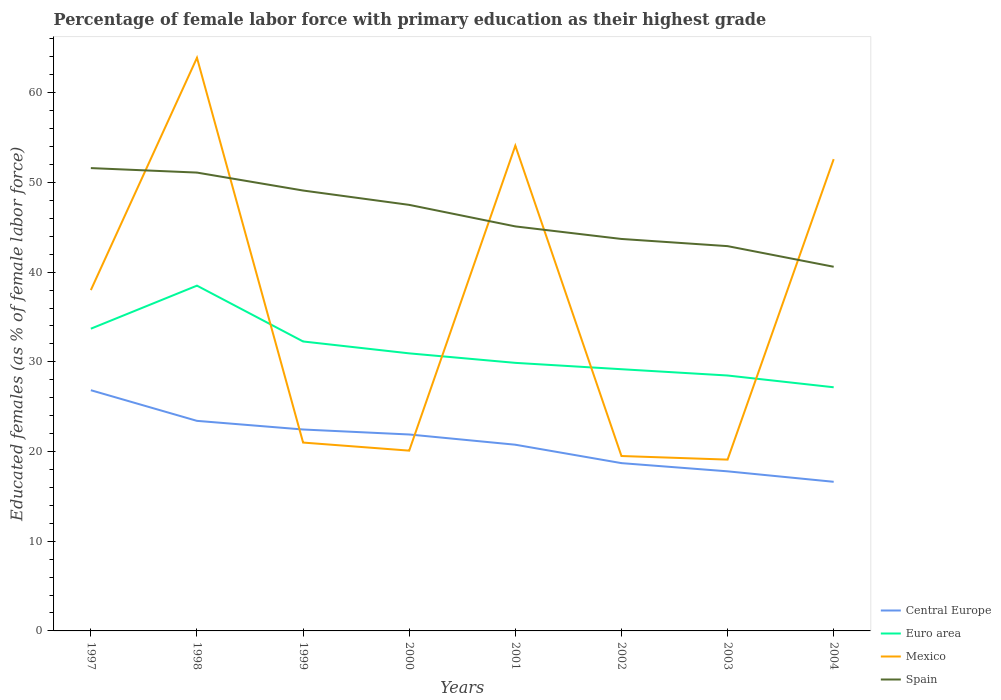How many different coloured lines are there?
Offer a terse response. 4. Across all years, what is the maximum percentage of female labor force with primary education in Mexico?
Your response must be concise. 19.1. What is the total percentage of female labor force with primary education in Euro area in the graph?
Your answer should be very brief. 6.53. What is the difference between the highest and the second highest percentage of female labor force with primary education in Central Europe?
Your answer should be compact. 10.21. What is the difference between the highest and the lowest percentage of female labor force with primary education in Euro area?
Make the answer very short. 3. How many years are there in the graph?
Your response must be concise. 8. What is the difference between two consecutive major ticks on the Y-axis?
Offer a terse response. 10. Does the graph contain any zero values?
Make the answer very short. No. How many legend labels are there?
Make the answer very short. 4. What is the title of the graph?
Offer a terse response. Percentage of female labor force with primary education as their highest grade. What is the label or title of the X-axis?
Provide a short and direct response. Years. What is the label or title of the Y-axis?
Offer a terse response. Educated females (as % of female labor force). What is the Educated females (as % of female labor force) of Central Europe in 1997?
Your answer should be very brief. 26.84. What is the Educated females (as % of female labor force) in Euro area in 1997?
Provide a succinct answer. 33.69. What is the Educated females (as % of female labor force) of Mexico in 1997?
Provide a succinct answer. 38. What is the Educated females (as % of female labor force) in Spain in 1997?
Provide a succinct answer. 51.6. What is the Educated females (as % of female labor force) of Central Europe in 1998?
Make the answer very short. 23.42. What is the Educated females (as % of female labor force) in Euro area in 1998?
Your answer should be very brief. 38.49. What is the Educated females (as % of female labor force) of Mexico in 1998?
Keep it short and to the point. 63.9. What is the Educated females (as % of female labor force) in Spain in 1998?
Keep it short and to the point. 51.1. What is the Educated females (as % of female labor force) of Central Europe in 1999?
Give a very brief answer. 22.46. What is the Educated females (as % of female labor force) of Euro area in 1999?
Your answer should be very brief. 32.27. What is the Educated females (as % of female labor force) of Mexico in 1999?
Offer a terse response. 21. What is the Educated females (as % of female labor force) in Spain in 1999?
Provide a short and direct response. 49.1. What is the Educated females (as % of female labor force) in Central Europe in 2000?
Ensure brevity in your answer.  21.9. What is the Educated females (as % of female labor force) of Euro area in 2000?
Provide a succinct answer. 30.95. What is the Educated females (as % of female labor force) of Mexico in 2000?
Provide a succinct answer. 20.1. What is the Educated females (as % of female labor force) of Spain in 2000?
Provide a succinct answer. 47.5. What is the Educated females (as % of female labor force) in Central Europe in 2001?
Offer a terse response. 20.76. What is the Educated females (as % of female labor force) in Euro area in 2001?
Offer a very short reply. 29.89. What is the Educated females (as % of female labor force) in Mexico in 2001?
Give a very brief answer. 54.1. What is the Educated females (as % of female labor force) of Spain in 2001?
Your answer should be very brief. 45.1. What is the Educated females (as % of female labor force) of Central Europe in 2002?
Ensure brevity in your answer.  18.71. What is the Educated females (as % of female labor force) in Euro area in 2002?
Ensure brevity in your answer.  29.18. What is the Educated females (as % of female labor force) of Mexico in 2002?
Give a very brief answer. 19.5. What is the Educated females (as % of female labor force) of Spain in 2002?
Your answer should be very brief. 43.7. What is the Educated females (as % of female labor force) of Central Europe in 2003?
Provide a short and direct response. 17.79. What is the Educated females (as % of female labor force) of Euro area in 2003?
Offer a terse response. 28.48. What is the Educated females (as % of female labor force) of Mexico in 2003?
Keep it short and to the point. 19.1. What is the Educated females (as % of female labor force) in Spain in 2003?
Offer a very short reply. 42.9. What is the Educated females (as % of female labor force) of Central Europe in 2004?
Ensure brevity in your answer.  16.63. What is the Educated females (as % of female labor force) of Euro area in 2004?
Give a very brief answer. 27.16. What is the Educated females (as % of female labor force) in Mexico in 2004?
Make the answer very short. 52.6. What is the Educated females (as % of female labor force) of Spain in 2004?
Your answer should be compact. 40.6. Across all years, what is the maximum Educated females (as % of female labor force) in Central Europe?
Provide a succinct answer. 26.84. Across all years, what is the maximum Educated females (as % of female labor force) in Euro area?
Provide a succinct answer. 38.49. Across all years, what is the maximum Educated females (as % of female labor force) of Mexico?
Ensure brevity in your answer.  63.9. Across all years, what is the maximum Educated females (as % of female labor force) of Spain?
Give a very brief answer. 51.6. Across all years, what is the minimum Educated females (as % of female labor force) of Central Europe?
Offer a terse response. 16.63. Across all years, what is the minimum Educated females (as % of female labor force) of Euro area?
Offer a terse response. 27.16. Across all years, what is the minimum Educated females (as % of female labor force) in Mexico?
Keep it short and to the point. 19.1. Across all years, what is the minimum Educated females (as % of female labor force) in Spain?
Make the answer very short. 40.6. What is the total Educated females (as % of female labor force) of Central Europe in the graph?
Offer a very short reply. 168.5. What is the total Educated females (as % of female labor force) in Euro area in the graph?
Offer a terse response. 250.11. What is the total Educated females (as % of female labor force) in Mexico in the graph?
Offer a very short reply. 288.3. What is the total Educated females (as % of female labor force) in Spain in the graph?
Ensure brevity in your answer.  371.6. What is the difference between the Educated females (as % of female labor force) in Central Europe in 1997 and that in 1998?
Your response must be concise. 3.42. What is the difference between the Educated females (as % of female labor force) in Euro area in 1997 and that in 1998?
Give a very brief answer. -4.8. What is the difference between the Educated females (as % of female labor force) of Mexico in 1997 and that in 1998?
Ensure brevity in your answer.  -25.9. What is the difference between the Educated females (as % of female labor force) of Central Europe in 1997 and that in 1999?
Provide a succinct answer. 4.38. What is the difference between the Educated females (as % of female labor force) of Euro area in 1997 and that in 1999?
Keep it short and to the point. 1.42. What is the difference between the Educated females (as % of female labor force) of Mexico in 1997 and that in 1999?
Provide a succinct answer. 17. What is the difference between the Educated females (as % of female labor force) in Central Europe in 1997 and that in 2000?
Ensure brevity in your answer.  4.93. What is the difference between the Educated females (as % of female labor force) of Euro area in 1997 and that in 2000?
Offer a terse response. 2.75. What is the difference between the Educated females (as % of female labor force) of Mexico in 1997 and that in 2000?
Make the answer very short. 17.9. What is the difference between the Educated females (as % of female labor force) in Spain in 1997 and that in 2000?
Ensure brevity in your answer.  4.1. What is the difference between the Educated females (as % of female labor force) of Central Europe in 1997 and that in 2001?
Provide a succinct answer. 6.08. What is the difference between the Educated females (as % of female labor force) of Euro area in 1997 and that in 2001?
Offer a very short reply. 3.81. What is the difference between the Educated females (as % of female labor force) of Mexico in 1997 and that in 2001?
Ensure brevity in your answer.  -16.1. What is the difference between the Educated females (as % of female labor force) in Spain in 1997 and that in 2001?
Your response must be concise. 6.5. What is the difference between the Educated females (as % of female labor force) of Central Europe in 1997 and that in 2002?
Your response must be concise. 8.13. What is the difference between the Educated females (as % of female labor force) in Euro area in 1997 and that in 2002?
Provide a succinct answer. 4.52. What is the difference between the Educated females (as % of female labor force) of Central Europe in 1997 and that in 2003?
Offer a terse response. 9.04. What is the difference between the Educated females (as % of female labor force) of Euro area in 1997 and that in 2003?
Ensure brevity in your answer.  5.22. What is the difference between the Educated females (as % of female labor force) in Mexico in 1997 and that in 2003?
Your answer should be very brief. 18.9. What is the difference between the Educated females (as % of female labor force) of Central Europe in 1997 and that in 2004?
Your answer should be very brief. 10.21. What is the difference between the Educated females (as % of female labor force) of Euro area in 1997 and that in 2004?
Give a very brief answer. 6.53. What is the difference between the Educated females (as % of female labor force) of Mexico in 1997 and that in 2004?
Provide a short and direct response. -14.6. What is the difference between the Educated females (as % of female labor force) in Spain in 1997 and that in 2004?
Give a very brief answer. 11. What is the difference between the Educated females (as % of female labor force) in Central Europe in 1998 and that in 1999?
Provide a succinct answer. 0.96. What is the difference between the Educated females (as % of female labor force) in Euro area in 1998 and that in 1999?
Offer a terse response. 6.22. What is the difference between the Educated females (as % of female labor force) of Mexico in 1998 and that in 1999?
Provide a succinct answer. 42.9. What is the difference between the Educated females (as % of female labor force) of Central Europe in 1998 and that in 2000?
Give a very brief answer. 1.52. What is the difference between the Educated females (as % of female labor force) of Euro area in 1998 and that in 2000?
Provide a succinct answer. 7.55. What is the difference between the Educated females (as % of female labor force) of Mexico in 1998 and that in 2000?
Your response must be concise. 43.8. What is the difference between the Educated females (as % of female labor force) of Central Europe in 1998 and that in 2001?
Your response must be concise. 2.66. What is the difference between the Educated females (as % of female labor force) of Euro area in 1998 and that in 2001?
Offer a terse response. 8.61. What is the difference between the Educated females (as % of female labor force) of Mexico in 1998 and that in 2001?
Give a very brief answer. 9.8. What is the difference between the Educated females (as % of female labor force) of Central Europe in 1998 and that in 2002?
Your response must be concise. 4.71. What is the difference between the Educated females (as % of female labor force) in Euro area in 1998 and that in 2002?
Offer a very short reply. 9.32. What is the difference between the Educated females (as % of female labor force) in Mexico in 1998 and that in 2002?
Offer a very short reply. 44.4. What is the difference between the Educated females (as % of female labor force) of Central Europe in 1998 and that in 2003?
Give a very brief answer. 5.63. What is the difference between the Educated females (as % of female labor force) of Euro area in 1998 and that in 2003?
Provide a short and direct response. 10.02. What is the difference between the Educated females (as % of female labor force) in Mexico in 1998 and that in 2003?
Your response must be concise. 44.8. What is the difference between the Educated females (as % of female labor force) in Central Europe in 1998 and that in 2004?
Give a very brief answer. 6.79. What is the difference between the Educated females (as % of female labor force) in Euro area in 1998 and that in 2004?
Give a very brief answer. 11.33. What is the difference between the Educated females (as % of female labor force) of Mexico in 1998 and that in 2004?
Your answer should be compact. 11.3. What is the difference between the Educated females (as % of female labor force) of Central Europe in 1999 and that in 2000?
Make the answer very short. 0.56. What is the difference between the Educated females (as % of female labor force) of Euro area in 1999 and that in 2000?
Provide a short and direct response. 1.33. What is the difference between the Educated females (as % of female labor force) in Mexico in 1999 and that in 2000?
Give a very brief answer. 0.9. What is the difference between the Educated females (as % of female labor force) in Spain in 1999 and that in 2000?
Your answer should be very brief. 1.6. What is the difference between the Educated females (as % of female labor force) of Central Europe in 1999 and that in 2001?
Give a very brief answer. 1.7. What is the difference between the Educated females (as % of female labor force) in Euro area in 1999 and that in 2001?
Make the answer very short. 2.39. What is the difference between the Educated females (as % of female labor force) of Mexico in 1999 and that in 2001?
Offer a very short reply. -33.1. What is the difference between the Educated females (as % of female labor force) of Central Europe in 1999 and that in 2002?
Offer a very short reply. 3.75. What is the difference between the Educated females (as % of female labor force) in Euro area in 1999 and that in 2002?
Make the answer very short. 3.09. What is the difference between the Educated females (as % of female labor force) in Mexico in 1999 and that in 2002?
Offer a very short reply. 1.5. What is the difference between the Educated females (as % of female labor force) of Central Europe in 1999 and that in 2003?
Provide a short and direct response. 4.66. What is the difference between the Educated females (as % of female labor force) in Euro area in 1999 and that in 2003?
Give a very brief answer. 3.79. What is the difference between the Educated females (as % of female labor force) of Mexico in 1999 and that in 2003?
Your answer should be very brief. 1.9. What is the difference between the Educated females (as % of female labor force) in Spain in 1999 and that in 2003?
Your answer should be compact. 6.2. What is the difference between the Educated females (as % of female labor force) of Central Europe in 1999 and that in 2004?
Offer a terse response. 5.83. What is the difference between the Educated females (as % of female labor force) of Euro area in 1999 and that in 2004?
Provide a short and direct response. 5.11. What is the difference between the Educated females (as % of female labor force) in Mexico in 1999 and that in 2004?
Offer a very short reply. -31.6. What is the difference between the Educated females (as % of female labor force) in Central Europe in 2000 and that in 2001?
Offer a very short reply. 1.14. What is the difference between the Educated females (as % of female labor force) in Euro area in 2000 and that in 2001?
Provide a succinct answer. 1.06. What is the difference between the Educated females (as % of female labor force) of Mexico in 2000 and that in 2001?
Offer a very short reply. -34. What is the difference between the Educated females (as % of female labor force) in Spain in 2000 and that in 2001?
Your response must be concise. 2.4. What is the difference between the Educated females (as % of female labor force) of Central Europe in 2000 and that in 2002?
Make the answer very short. 3.19. What is the difference between the Educated females (as % of female labor force) in Euro area in 2000 and that in 2002?
Provide a short and direct response. 1.77. What is the difference between the Educated females (as % of female labor force) in Spain in 2000 and that in 2002?
Your response must be concise. 3.8. What is the difference between the Educated females (as % of female labor force) of Central Europe in 2000 and that in 2003?
Your response must be concise. 4.11. What is the difference between the Educated females (as % of female labor force) of Euro area in 2000 and that in 2003?
Offer a terse response. 2.47. What is the difference between the Educated females (as % of female labor force) of Mexico in 2000 and that in 2003?
Your answer should be very brief. 1. What is the difference between the Educated females (as % of female labor force) of Central Europe in 2000 and that in 2004?
Make the answer very short. 5.28. What is the difference between the Educated females (as % of female labor force) in Euro area in 2000 and that in 2004?
Your answer should be very brief. 3.78. What is the difference between the Educated females (as % of female labor force) in Mexico in 2000 and that in 2004?
Give a very brief answer. -32.5. What is the difference between the Educated females (as % of female labor force) in Spain in 2000 and that in 2004?
Give a very brief answer. 6.9. What is the difference between the Educated females (as % of female labor force) of Central Europe in 2001 and that in 2002?
Your answer should be very brief. 2.05. What is the difference between the Educated females (as % of female labor force) of Euro area in 2001 and that in 2002?
Keep it short and to the point. 0.71. What is the difference between the Educated females (as % of female labor force) of Mexico in 2001 and that in 2002?
Your response must be concise. 34.6. What is the difference between the Educated females (as % of female labor force) of Central Europe in 2001 and that in 2003?
Offer a terse response. 2.97. What is the difference between the Educated females (as % of female labor force) of Euro area in 2001 and that in 2003?
Make the answer very short. 1.41. What is the difference between the Educated females (as % of female labor force) of Central Europe in 2001 and that in 2004?
Provide a short and direct response. 4.13. What is the difference between the Educated females (as % of female labor force) in Euro area in 2001 and that in 2004?
Your answer should be very brief. 2.72. What is the difference between the Educated females (as % of female labor force) in Central Europe in 2002 and that in 2003?
Offer a very short reply. 0.91. What is the difference between the Educated females (as % of female labor force) in Euro area in 2002 and that in 2003?
Ensure brevity in your answer.  0.7. What is the difference between the Educated females (as % of female labor force) in Mexico in 2002 and that in 2003?
Provide a short and direct response. 0.4. What is the difference between the Educated females (as % of female labor force) of Central Europe in 2002 and that in 2004?
Give a very brief answer. 2.08. What is the difference between the Educated females (as % of female labor force) of Euro area in 2002 and that in 2004?
Ensure brevity in your answer.  2.01. What is the difference between the Educated females (as % of female labor force) in Mexico in 2002 and that in 2004?
Give a very brief answer. -33.1. What is the difference between the Educated females (as % of female labor force) in Central Europe in 2003 and that in 2004?
Provide a succinct answer. 1.17. What is the difference between the Educated females (as % of female labor force) in Euro area in 2003 and that in 2004?
Keep it short and to the point. 1.31. What is the difference between the Educated females (as % of female labor force) in Mexico in 2003 and that in 2004?
Ensure brevity in your answer.  -33.5. What is the difference between the Educated females (as % of female labor force) of Central Europe in 1997 and the Educated females (as % of female labor force) of Euro area in 1998?
Make the answer very short. -11.66. What is the difference between the Educated females (as % of female labor force) in Central Europe in 1997 and the Educated females (as % of female labor force) in Mexico in 1998?
Keep it short and to the point. -37.06. What is the difference between the Educated females (as % of female labor force) in Central Europe in 1997 and the Educated females (as % of female labor force) in Spain in 1998?
Provide a succinct answer. -24.26. What is the difference between the Educated females (as % of female labor force) of Euro area in 1997 and the Educated females (as % of female labor force) of Mexico in 1998?
Provide a short and direct response. -30.21. What is the difference between the Educated females (as % of female labor force) in Euro area in 1997 and the Educated females (as % of female labor force) in Spain in 1998?
Ensure brevity in your answer.  -17.41. What is the difference between the Educated females (as % of female labor force) in Mexico in 1997 and the Educated females (as % of female labor force) in Spain in 1998?
Provide a succinct answer. -13.1. What is the difference between the Educated females (as % of female labor force) in Central Europe in 1997 and the Educated females (as % of female labor force) in Euro area in 1999?
Give a very brief answer. -5.44. What is the difference between the Educated females (as % of female labor force) of Central Europe in 1997 and the Educated females (as % of female labor force) of Mexico in 1999?
Make the answer very short. 5.84. What is the difference between the Educated females (as % of female labor force) in Central Europe in 1997 and the Educated females (as % of female labor force) in Spain in 1999?
Offer a terse response. -22.26. What is the difference between the Educated females (as % of female labor force) of Euro area in 1997 and the Educated females (as % of female labor force) of Mexico in 1999?
Offer a terse response. 12.69. What is the difference between the Educated females (as % of female labor force) in Euro area in 1997 and the Educated females (as % of female labor force) in Spain in 1999?
Provide a succinct answer. -15.41. What is the difference between the Educated females (as % of female labor force) of Mexico in 1997 and the Educated females (as % of female labor force) of Spain in 1999?
Offer a very short reply. -11.1. What is the difference between the Educated females (as % of female labor force) of Central Europe in 1997 and the Educated females (as % of female labor force) of Euro area in 2000?
Keep it short and to the point. -4.11. What is the difference between the Educated females (as % of female labor force) of Central Europe in 1997 and the Educated females (as % of female labor force) of Mexico in 2000?
Your answer should be compact. 6.74. What is the difference between the Educated females (as % of female labor force) of Central Europe in 1997 and the Educated females (as % of female labor force) of Spain in 2000?
Make the answer very short. -20.66. What is the difference between the Educated females (as % of female labor force) of Euro area in 1997 and the Educated females (as % of female labor force) of Mexico in 2000?
Offer a very short reply. 13.59. What is the difference between the Educated females (as % of female labor force) in Euro area in 1997 and the Educated females (as % of female labor force) in Spain in 2000?
Ensure brevity in your answer.  -13.81. What is the difference between the Educated females (as % of female labor force) in Mexico in 1997 and the Educated females (as % of female labor force) in Spain in 2000?
Keep it short and to the point. -9.5. What is the difference between the Educated females (as % of female labor force) in Central Europe in 1997 and the Educated females (as % of female labor force) in Euro area in 2001?
Offer a terse response. -3.05. What is the difference between the Educated females (as % of female labor force) in Central Europe in 1997 and the Educated females (as % of female labor force) in Mexico in 2001?
Offer a terse response. -27.26. What is the difference between the Educated females (as % of female labor force) in Central Europe in 1997 and the Educated females (as % of female labor force) in Spain in 2001?
Provide a short and direct response. -18.26. What is the difference between the Educated females (as % of female labor force) in Euro area in 1997 and the Educated females (as % of female labor force) in Mexico in 2001?
Provide a short and direct response. -20.41. What is the difference between the Educated females (as % of female labor force) of Euro area in 1997 and the Educated females (as % of female labor force) of Spain in 2001?
Provide a short and direct response. -11.41. What is the difference between the Educated females (as % of female labor force) in Mexico in 1997 and the Educated females (as % of female labor force) in Spain in 2001?
Ensure brevity in your answer.  -7.1. What is the difference between the Educated females (as % of female labor force) of Central Europe in 1997 and the Educated females (as % of female labor force) of Euro area in 2002?
Your answer should be compact. -2.34. What is the difference between the Educated females (as % of female labor force) of Central Europe in 1997 and the Educated females (as % of female labor force) of Mexico in 2002?
Your answer should be very brief. 7.34. What is the difference between the Educated females (as % of female labor force) of Central Europe in 1997 and the Educated females (as % of female labor force) of Spain in 2002?
Provide a short and direct response. -16.86. What is the difference between the Educated females (as % of female labor force) of Euro area in 1997 and the Educated females (as % of female labor force) of Mexico in 2002?
Your answer should be compact. 14.19. What is the difference between the Educated females (as % of female labor force) in Euro area in 1997 and the Educated females (as % of female labor force) in Spain in 2002?
Provide a short and direct response. -10.01. What is the difference between the Educated females (as % of female labor force) in Mexico in 1997 and the Educated females (as % of female labor force) in Spain in 2002?
Make the answer very short. -5.7. What is the difference between the Educated females (as % of female labor force) of Central Europe in 1997 and the Educated females (as % of female labor force) of Euro area in 2003?
Ensure brevity in your answer.  -1.64. What is the difference between the Educated females (as % of female labor force) in Central Europe in 1997 and the Educated females (as % of female labor force) in Mexico in 2003?
Keep it short and to the point. 7.74. What is the difference between the Educated females (as % of female labor force) of Central Europe in 1997 and the Educated females (as % of female labor force) of Spain in 2003?
Make the answer very short. -16.06. What is the difference between the Educated females (as % of female labor force) in Euro area in 1997 and the Educated females (as % of female labor force) in Mexico in 2003?
Provide a succinct answer. 14.59. What is the difference between the Educated females (as % of female labor force) of Euro area in 1997 and the Educated females (as % of female labor force) of Spain in 2003?
Give a very brief answer. -9.21. What is the difference between the Educated females (as % of female labor force) in Mexico in 1997 and the Educated females (as % of female labor force) in Spain in 2003?
Offer a terse response. -4.9. What is the difference between the Educated females (as % of female labor force) of Central Europe in 1997 and the Educated females (as % of female labor force) of Euro area in 2004?
Your response must be concise. -0.33. What is the difference between the Educated females (as % of female labor force) of Central Europe in 1997 and the Educated females (as % of female labor force) of Mexico in 2004?
Make the answer very short. -25.76. What is the difference between the Educated females (as % of female labor force) in Central Europe in 1997 and the Educated females (as % of female labor force) in Spain in 2004?
Offer a very short reply. -13.76. What is the difference between the Educated females (as % of female labor force) in Euro area in 1997 and the Educated females (as % of female labor force) in Mexico in 2004?
Offer a very short reply. -18.91. What is the difference between the Educated females (as % of female labor force) in Euro area in 1997 and the Educated females (as % of female labor force) in Spain in 2004?
Keep it short and to the point. -6.91. What is the difference between the Educated females (as % of female labor force) of Mexico in 1997 and the Educated females (as % of female labor force) of Spain in 2004?
Your response must be concise. -2.6. What is the difference between the Educated females (as % of female labor force) in Central Europe in 1998 and the Educated females (as % of female labor force) in Euro area in 1999?
Give a very brief answer. -8.85. What is the difference between the Educated females (as % of female labor force) in Central Europe in 1998 and the Educated females (as % of female labor force) in Mexico in 1999?
Ensure brevity in your answer.  2.42. What is the difference between the Educated females (as % of female labor force) of Central Europe in 1998 and the Educated females (as % of female labor force) of Spain in 1999?
Provide a short and direct response. -25.68. What is the difference between the Educated females (as % of female labor force) of Euro area in 1998 and the Educated females (as % of female labor force) of Mexico in 1999?
Make the answer very short. 17.49. What is the difference between the Educated females (as % of female labor force) of Euro area in 1998 and the Educated females (as % of female labor force) of Spain in 1999?
Make the answer very short. -10.61. What is the difference between the Educated females (as % of female labor force) of Mexico in 1998 and the Educated females (as % of female labor force) of Spain in 1999?
Provide a succinct answer. 14.8. What is the difference between the Educated females (as % of female labor force) of Central Europe in 1998 and the Educated females (as % of female labor force) of Euro area in 2000?
Make the answer very short. -7.53. What is the difference between the Educated females (as % of female labor force) of Central Europe in 1998 and the Educated females (as % of female labor force) of Mexico in 2000?
Offer a very short reply. 3.32. What is the difference between the Educated females (as % of female labor force) in Central Europe in 1998 and the Educated females (as % of female labor force) in Spain in 2000?
Offer a very short reply. -24.08. What is the difference between the Educated females (as % of female labor force) of Euro area in 1998 and the Educated females (as % of female labor force) of Mexico in 2000?
Your answer should be very brief. 18.39. What is the difference between the Educated females (as % of female labor force) of Euro area in 1998 and the Educated females (as % of female labor force) of Spain in 2000?
Offer a terse response. -9.01. What is the difference between the Educated females (as % of female labor force) of Central Europe in 1998 and the Educated females (as % of female labor force) of Euro area in 2001?
Provide a succinct answer. -6.47. What is the difference between the Educated females (as % of female labor force) in Central Europe in 1998 and the Educated females (as % of female labor force) in Mexico in 2001?
Provide a succinct answer. -30.68. What is the difference between the Educated females (as % of female labor force) in Central Europe in 1998 and the Educated females (as % of female labor force) in Spain in 2001?
Give a very brief answer. -21.68. What is the difference between the Educated females (as % of female labor force) in Euro area in 1998 and the Educated females (as % of female labor force) in Mexico in 2001?
Keep it short and to the point. -15.61. What is the difference between the Educated females (as % of female labor force) in Euro area in 1998 and the Educated females (as % of female labor force) in Spain in 2001?
Make the answer very short. -6.61. What is the difference between the Educated females (as % of female labor force) in Central Europe in 1998 and the Educated females (as % of female labor force) in Euro area in 2002?
Your response must be concise. -5.76. What is the difference between the Educated females (as % of female labor force) of Central Europe in 1998 and the Educated females (as % of female labor force) of Mexico in 2002?
Your answer should be very brief. 3.92. What is the difference between the Educated females (as % of female labor force) in Central Europe in 1998 and the Educated females (as % of female labor force) in Spain in 2002?
Make the answer very short. -20.28. What is the difference between the Educated females (as % of female labor force) in Euro area in 1998 and the Educated females (as % of female labor force) in Mexico in 2002?
Provide a succinct answer. 18.99. What is the difference between the Educated females (as % of female labor force) in Euro area in 1998 and the Educated females (as % of female labor force) in Spain in 2002?
Provide a short and direct response. -5.21. What is the difference between the Educated females (as % of female labor force) of Mexico in 1998 and the Educated females (as % of female labor force) of Spain in 2002?
Provide a succinct answer. 20.2. What is the difference between the Educated females (as % of female labor force) in Central Europe in 1998 and the Educated females (as % of female labor force) in Euro area in 2003?
Offer a terse response. -5.06. What is the difference between the Educated females (as % of female labor force) in Central Europe in 1998 and the Educated females (as % of female labor force) in Mexico in 2003?
Offer a terse response. 4.32. What is the difference between the Educated females (as % of female labor force) of Central Europe in 1998 and the Educated females (as % of female labor force) of Spain in 2003?
Keep it short and to the point. -19.48. What is the difference between the Educated females (as % of female labor force) of Euro area in 1998 and the Educated females (as % of female labor force) of Mexico in 2003?
Your answer should be very brief. 19.39. What is the difference between the Educated females (as % of female labor force) in Euro area in 1998 and the Educated females (as % of female labor force) in Spain in 2003?
Provide a succinct answer. -4.41. What is the difference between the Educated females (as % of female labor force) in Mexico in 1998 and the Educated females (as % of female labor force) in Spain in 2003?
Make the answer very short. 21. What is the difference between the Educated females (as % of female labor force) of Central Europe in 1998 and the Educated females (as % of female labor force) of Euro area in 2004?
Make the answer very short. -3.74. What is the difference between the Educated females (as % of female labor force) of Central Europe in 1998 and the Educated females (as % of female labor force) of Mexico in 2004?
Offer a very short reply. -29.18. What is the difference between the Educated females (as % of female labor force) in Central Europe in 1998 and the Educated females (as % of female labor force) in Spain in 2004?
Your answer should be very brief. -17.18. What is the difference between the Educated females (as % of female labor force) in Euro area in 1998 and the Educated females (as % of female labor force) in Mexico in 2004?
Ensure brevity in your answer.  -14.11. What is the difference between the Educated females (as % of female labor force) in Euro area in 1998 and the Educated females (as % of female labor force) in Spain in 2004?
Provide a succinct answer. -2.11. What is the difference between the Educated females (as % of female labor force) in Mexico in 1998 and the Educated females (as % of female labor force) in Spain in 2004?
Your response must be concise. 23.3. What is the difference between the Educated females (as % of female labor force) of Central Europe in 1999 and the Educated females (as % of female labor force) of Euro area in 2000?
Offer a terse response. -8.49. What is the difference between the Educated females (as % of female labor force) of Central Europe in 1999 and the Educated females (as % of female labor force) of Mexico in 2000?
Your answer should be very brief. 2.36. What is the difference between the Educated females (as % of female labor force) in Central Europe in 1999 and the Educated females (as % of female labor force) in Spain in 2000?
Offer a very short reply. -25.04. What is the difference between the Educated females (as % of female labor force) of Euro area in 1999 and the Educated females (as % of female labor force) of Mexico in 2000?
Keep it short and to the point. 12.17. What is the difference between the Educated females (as % of female labor force) of Euro area in 1999 and the Educated females (as % of female labor force) of Spain in 2000?
Give a very brief answer. -15.23. What is the difference between the Educated females (as % of female labor force) in Mexico in 1999 and the Educated females (as % of female labor force) in Spain in 2000?
Give a very brief answer. -26.5. What is the difference between the Educated females (as % of female labor force) in Central Europe in 1999 and the Educated females (as % of female labor force) in Euro area in 2001?
Offer a very short reply. -7.43. What is the difference between the Educated females (as % of female labor force) in Central Europe in 1999 and the Educated females (as % of female labor force) in Mexico in 2001?
Keep it short and to the point. -31.64. What is the difference between the Educated females (as % of female labor force) in Central Europe in 1999 and the Educated females (as % of female labor force) in Spain in 2001?
Your response must be concise. -22.64. What is the difference between the Educated females (as % of female labor force) of Euro area in 1999 and the Educated females (as % of female labor force) of Mexico in 2001?
Your response must be concise. -21.83. What is the difference between the Educated females (as % of female labor force) in Euro area in 1999 and the Educated females (as % of female labor force) in Spain in 2001?
Your response must be concise. -12.83. What is the difference between the Educated females (as % of female labor force) of Mexico in 1999 and the Educated females (as % of female labor force) of Spain in 2001?
Offer a very short reply. -24.1. What is the difference between the Educated females (as % of female labor force) of Central Europe in 1999 and the Educated females (as % of female labor force) of Euro area in 2002?
Keep it short and to the point. -6.72. What is the difference between the Educated females (as % of female labor force) of Central Europe in 1999 and the Educated females (as % of female labor force) of Mexico in 2002?
Provide a succinct answer. 2.96. What is the difference between the Educated females (as % of female labor force) of Central Europe in 1999 and the Educated females (as % of female labor force) of Spain in 2002?
Keep it short and to the point. -21.24. What is the difference between the Educated females (as % of female labor force) of Euro area in 1999 and the Educated females (as % of female labor force) of Mexico in 2002?
Your answer should be compact. 12.77. What is the difference between the Educated females (as % of female labor force) of Euro area in 1999 and the Educated females (as % of female labor force) of Spain in 2002?
Give a very brief answer. -11.43. What is the difference between the Educated females (as % of female labor force) of Mexico in 1999 and the Educated females (as % of female labor force) of Spain in 2002?
Ensure brevity in your answer.  -22.7. What is the difference between the Educated females (as % of female labor force) in Central Europe in 1999 and the Educated females (as % of female labor force) in Euro area in 2003?
Offer a very short reply. -6.02. What is the difference between the Educated females (as % of female labor force) of Central Europe in 1999 and the Educated females (as % of female labor force) of Mexico in 2003?
Offer a very short reply. 3.36. What is the difference between the Educated females (as % of female labor force) in Central Europe in 1999 and the Educated females (as % of female labor force) in Spain in 2003?
Your response must be concise. -20.44. What is the difference between the Educated females (as % of female labor force) of Euro area in 1999 and the Educated females (as % of female labor force) of Mexico in 2003?
Give a very brief answer. 13.17. What is the difference between the Educated females (as % of female labor force) of Euro area in 1999 and the Educated females (as % of female labor force) of Spain in 2003?
Make the answer very short. -10.63. What is the difference between the Educated females (as % of female labor force) in Mexico in 1999 and the Educated females (as % of female labor force) in Spain in 2003?
Your response must be concise. -21.9. What is the difference between the Educated females (as % of female labor force) in Central Europe in 1999 and the Educated females (as % of female labor force) in Euro area in 2004?
Ensure brevity in your answer.  -4.71. What is the difference between the Educated females (as % of female labor force) in Central Europe in 1999 and the Educated females (as % of female labor force) in Mexico in 2004?
Keep it short and to the point. -30.14. What is the difference between the Educated females (as % of female labor force) in Central Europe in 1999 and the Educated females (as % of female labor force) in Spain in 2004?
Your answer should be compact. -18.14. What is the difference between the Educated females (as % of female labor force) of Euro area in 1999 and the Educated females (as % of female labor force) of Mexico in 2004?
Make the answer very short. -20.33. What is the difference between the Educated females (as % of female labor force) in Euro area in 1999 and the Educated females (as % of female labor force) in Spain in 2004?
Give a very brief answer. -8.33. What is the difference between the Educated females (as % of female labor force) in Mexico in 1999 and the Educated females (as % of female labor force) in Spain in 2004?
Ensure brevity in your answer.  -19.6. What is the difference between the Educated females (as % of female labor force) of Central Europe in 2000 and the Educated females (as % of female labor force) of Euro area in 2001?
Keep it short and to the point. -7.98. What is the difference between the Educated females (as % of female labor force) of Central Europe in 2000 and the Educated females (as % of female labor force) of Mexico in 2001?
Your answer should be compact. -32.2. What is the difference between the Educated females (as % of female labor force) of Central Europe in 2000 and the Educated females (as % of female labor force) of Spain in 2001?
Offer a terse response. -23.2. What is the difference between the Educated females (as % of female labor force) in Euro area in 2000 and the Educated females (as % of female labor force) in Mexico in 2001?
Your response must be concise. -23.15. What is the difference between the Educated females (as % of female labor force) of Euro area in 2000 and the Educated females (as % of female labor force) of Spain in 2001?
Your response must be concise. -14.15. What is the difference between the Educated females (as % of female labor force) in Central Europe in 2000 and the Educated females (as % of female labor force) in Euro area in 2002?
Provide a succinct answer. -7.28. What is the difference between the Educated females (as % of female labor force) in Central Europe in 2000 and the Educated females (as % of female labor force) in Mexico in 2002?
Offer a very short reply. 2.4. What is the difference between the Educated females (as % of female labor force) in Central Europe in 2000 and the Educated females (as % of female labor force) in Spain in 2002?
Make the answer very short. -21.8. What is the difference between the Educated females (as % of female labor force) in Euro area in 2000 and the Educated females (as % of female labor force) in Mexico in 2002?
Provide a short and direct response. 11.45. What is the difference between the Educated females (as % of female labor force) of Euro area in 2000 and the Educated females (as % of female labor force) of Spain in 2002?
Your response must be concise. -12.75. What is the difference between the Educated females (as % of female labor force) of Mexico in 2000 and the Educated females (as % of female labor force) of Spain in 2002?
Ensure brevity in your answer.  -23.6. What is the difference between the Educated females (as % of female labor force) of Central Europe in 2000 and the Educated females (as % of female labor force) of Euro area in 2003?
Provide a short and direct response. -6.58. What is the difference between the Educated females (as % of female labor force) in Central Europe in 2000 and the Educated females (as % of female labor force) in Mexico in 2003?
Keep it short and to the point. 2.8. What is the difference between the Educated females (as % of female labor force) of Central Europe in 2000 and the Educated females (as % of female labor force) of Spain in 2003?
Offer a very short reply. -21. What is the difference between the Educated females (as % of female labor force) in Euro area in 2000 and the Educated females (as % of female labor force) in Mexico in 2003?
Your response must be concise. 11.85. What is the difference between the Educated females (as % of female labor force) of Euro area in 2000 and the Educated females (as % of female labor force) of Spain in 2003?
Your response must be concise. -11.95. What is the difference between the Educated females (as % of female labor force) in Mexico in 2000 and the Educated females (as % of female labor force) in Spain in 2003?
Make the answer very short. -22.8. What is the difference between the Educated females (as % of female labor force) of Central Europe in 2000 and the Educated females (as % of female labor force) of Euro area in 2004?
Keep it short and to the point. -5.26. What is the difference between the Educated females (as % of female labor force) of Central Europe in 2000 and the Educated females (as % of female labor force) of Mexico in 2004?
Ensure brevity in your answer.  -30.7. What is the difference between the Educated females (as % of female labor force) of Central Europe in 2000 and the Educated females (as % of female labor force) of Spain in 2004?
Your answer should be compact. -18.7. What is the difference between the Educated females (as % of female labor force) in Euro area in 2000 and the Educated females (as % of female labor force) in Mexico in 2004?
Your response must be concise. -21.65. What is the difference between the Educated females (as % of female labor force) in Euro area in 2000 and the Educated females (as % of female labor force) in Spain in 2004?
Offer a terse response. -9.65. What is the difference between the Educated females (as % of female labor force) of Mexico in 2000 and the Educated females (as % of female labor force) of Spain in 2004?
Ensure brevity in your answer.  -20.5. What is the difference between the Educated females (as % of female labor force) in Central Europe in 2001 and the Educated females (as % of female labor force) in Euro area in 2002?
Keep it short and to the point. -8.42. What is the difference between the Educated females (as % of female labor force) of Central Europe in 2001 and the Educated females (as % of female labor force) of Mexico in 2002?
Your response must be concise. 1.26. What is the difference between the Educated females (as % of female labor force) in Central Europe in 2001 and the Educated females (as % of female labor force) in Spain in 2002?
Your answer should be compact. -22.94. What is the difference between the Educated females (as % of female labor force) of Euro area in 2001 and the Educated females (as % of female labor force) of Mexico in 2002?
Make the answer very short. 10.39. What is the difference between the Educated females (as % of female labor force) in Euro area in 2001 and the Educated females (as % of female labor force) in Spain in 2002?
Provide a succinct answer. -13.81. What is the difference between the Educated females (as % of female labor force) of Central Europe in 2001 and the Educated females (as % of female labor force) of Euro area in 2003?
Your answer should be very brief. -7.72. What is the difference between the Educated females (as % of female labor force) of Central Europe in 2001 and the Educated females (as % of female labor force) of Mexico in 2003?
Offer a terse response. 1.66. What is the difference between the Educated females (as % of female labor force) of Central Europe in 2001 and the Educated females (as % of female labor force) of Spain in 2003?
Make the answer very short. -22.14. What is the difference between the Educated females (as % of female labor force) of Euro area in 2001 and the Educated females (as % of female labor force) of Mexico in 2003?
Your answer should be very brief. 10.79. What is the difference between the Educated females (as % of female labor force) of Euro area in 2001 and the Educated females (as % of female labor force) of Spain in 2003?
Make the answer very short. -13.01. What is the difference between the Educated females (as % of female labor force) of Mexico in 2001 and the Educated females (as % of female labor force) of Spain in 2003?
Keep it short and to the point. 11.2. What is the difference between the Educated females (as % of female labor force) in Central Europe in 2001 and the Educated females (as % of female labor force) in Euro area in 2004?
Ensure brevity in your answer.  -6.4. What is the difference between the Educated females (as % of female labor force) in Central Europe in 2001 and the Educated females (as % of female labor force) in Mexico in 2004?
Provide a succinct answer. -31.84. What is the difference between the Educated females (as % of female labor force) in Central Europe in 2001 and the Educated females (as % of female labor force) in Spain in 2004?
Give a very brief answer. -19.84. What is the difference between the Educated females (as % of female labor force) of Euro area in 2001 and the Educated females (as % of female labor force) of Mexico in 2004?
Keep it short and to the point. -22.71. What is the difference between the Educated females (as % of female labor force) of Euro area in 2001 and the Educated females (as % of female labor force) of Spain in 2004?
Provide a short and direct response. -10.71. What is the difference between the Educated females (as % of female labor force) of Mexico in 2001 and the Educated females (as % of female labor force) of Spain in 2004?
Ensure brevity in your answer.  13.5. What is the difference between the Educated females (as % of female labor force) of Central Europe in 2002 and the Educated females (as % of female labor force) of Euro area in 2003?
Make the answer very short. -9.77. What is the difference between the Educated females (as % of female labor force) of Central Europe in 2002 and the Educated females (as % of female labor force) of Mexico in 2003?
Provide a short and direct response. -0.39. What is the difference between the Educated females (as % of female labor force) in Central Europe in 2002 and the Educated females (as % of female labor force) in Spain in 2003?
Offer a terse response. -24.19. What is the difference between the Educated females (as % of female labor force) of Euro area in 2002 and the Educated females (as % of female labor force) of Mexico in 2003?
Offer a terse response. 10.08. What is the difference between the Educated females (as % of female labor force) in Euro area in 2002 and the Educated females (as % of female labor force) in Spain in 2003?
Your answer should be very brief. -13.72. What is the difference between the Educated females (as % of female labor force) of Mexico in 2002 and the Educated females (as % of female labor force) of Spain in 2003?
Your answer should be very brief. -23.4. What is the difference between the Educated females (as % of female labor force) in Central Europe in 2002 and the Educated females (as % of female labor force) in Euro area in 2004?
Provide a succinct answer. -8.46. What is the difference between the Educated females (as % of female labor force) of Central Europe in 2002 and the Educated females (as % of female labor force) of Mexico in 2004?
Give a very brief answer. -33.89. What is the difference between the Educated females (as % of female labor force) of Central Europe in 2002 and the Educated females (as % of female labor force) of Spain in 2004?
Give a very brief answer. -21.89. What is the difference between the Educated females (as % of female labor force) in Euro area in 2002 and the Educated females (as % of female labor force) in Mexico in 2004?
Your answer should be very brief. -23.42. What is the difference between the Educated females (as % of female labor force) of Euro area in 2002 and the Educated females (as % of female labor force) of Spain in 2004?
Offer a very short reply. -11.42. What is the difference between the Educated females (as % of female labor force) in Mexico in 2002 and the Educated females (as % of female labor force) in Spain in 2004?
Your answer should be very brief. -21.1. What is the difference between the Educated females (as % of female labor force) in Central Europe in 2003 and the Educated females (as % of female labor force) in Euro area in 2004?
Your answer should be compact. -9.37. What is the difference between the Educated females (as % of female labor force) of Central Europe in 2003 and the Educated females (as % of female labor force) of Mexico in 2004?
Provide a short and direct response. -34.81. What is the difference between the Educated females (as % of female labor force) of Central Europe in 2003 and the Educated females (as % of female labor force) of Spain in 2004?
Provide a succinct answer. -22.81. What is the difference between the Educated females (as % of female labor force) of Euro area in 2003 and the Educated females (as % of female labor force) of Mexico in 2004?
Offer a terse response. -24.12. What is the difference between the Educated females (as % of female labor force) of Euro area in 2003 and the Educated females (as % of female labor force) of Spain in 2004?
Provide a succinct answer. -12.12. What is the difference between the Educated females (as % of female labor force) of Mexico in 2003 and the Educated females (as % of female labor force) of Spain in 2004?
Offer a very short reply. -21.5. What is the average Educated females (as % of female labor force) of Central Europe per year?
Your response must be concise. 21.06. What is the average Educated females (as % of female labor force) of Euro area per year?
Ensure brevity in your answer.  31.26. What is the average Educated females (as % of female labor force) in Mexico per year?
Offer a very short reply. 36.04. What is the average Educated females (as % of female labor force) in Spain per year?
Your answer should be compact. 46.45. In the year 1997, what is the difference between the Educated females (as % of female labor force) of Central Europe and Educated females (as % of female labor force) of Euro area?
Provide a succinct answer. -6.86. In the year 1997, what is the difference between the Educated females (as % of female labor force) of Central Europe and Educated females (as % of female labor force) of Mexico?
Provide a succinct answer. -11.16. In the year 1997, what is the difference between the Educated females (as % of female labor force) in Central Europe and Educated females (as % of female labor force) in Spain?
Give a very brief answer. -24.76. In the year 1997, what is the difference between the Educated females (as % of female labor force) of Euro area and Educated females (as % of female labor force) of Mexico?
Provide a short and direct response. -4.31. In the year 1997, what is the difference between the Educated females (as % of female labor force) in Euro area and Educated females (as % of female labor force) in Spain?
Make the answer very short. -17.91. In the year 1997, what is the difference between the Educated females (as % of female labor force) of Mexico and Educated females (as % of female labor force) of Spain?
Your response must be concise. -13.6. In the year 1998, what is the difference between the Educated females (as % of female labor force) of Central Europe and Educated females (as % of female labor force) of Euro area?
Your response must be concise. -15.07. In the year 1998, what is the difference between the Educated females (as % of female labor force) of Central Europe and Educated females (as % of female labor force) of Mexico?
Give a very brief answer. -40.48. In the year 1998, what is the difference between the Educated females (as % of female labor force) of Central Europe and Educated females (as % of female labor force) of Spain?
Your answer should be very brief. -27.68. In the year 1998, what is the difference between the Educated females (as % of female labor force) in Euro area and Educated females (as % of female labor force) in Mexico?
Ensure brevity in your answer.  -25.41. In the year 1998, what is the difference between the Educated females (as % of female labor force) in Euro area and Educated females (as % of female labor force) in Spain?
Offer a very short reply. -12.61. In the year 1999, what is the difference between the Educated females (as % of female labor force) of Central Europe and Educated females (as % of female labor force) of Euro area?
Provide a succinct answer. -9.81. In the year 1999, what is the difference between the Educated females (as % of female labor force) in Central Europe and Educated females (as % of female labor force) in Mexico?
Make the answer very short. 1.46. In the year 1999, what is the difference between the Educated females (as % of female labor force) in Central Europe and Educated females (as % of female labor force) in Spain?
Offer a terse response. -26.64. In the year 1999, what is the difference between the Educated females (as % of female labor force) of Euro area and Educated females (as % of female labor force) of Mexico?
Provide a succinct answer. 11.27. In the year 1999, what is the difference between the Educated females (as % of female labor force) in Euro area and Educated females (as % of female labor force) in Spain?
Your response must be concise. -16.83. In the year 1999, what is the difference between the Educated females (as % of female labor force) of Mexico and Educated females (as % of female labor force) of Spain?
Your response must be concise. -28.1. In the year 2000, what is the difference between the Educated females (as % of female labor force) in Central Europe and Educated females (as % of female labor force) in Euro area?
Make the answer very short. -9.04. In the year 2000, what is the difference between the Educated females (as % of female labor force) in Central Europe and Educated females (as % of female labor force) in Mexico?
Offer a terse response. 1.8. In the year 2000, what is the difference between the Educated females (as % of female labor force) of Central Europe and Educated females (as % of female labor force) of Spain?
Your answer should be compact. -25.6. In the year 2000, what is the difference between the Educated females (as % of female labor force) of Euro area and Educated females (as % of female labor force) of Mexico?
Provide a short and direct response. 10.85. In the year 2000, what is the difference between the Educated females (as % of female labor force) of Euro area and Educated females (as % of female labor force) of Spain?
Provide a short and direct response. -16.55. In the year 2000, what is the difference between the Educated females (as % of female labor force) in Mexico and Educated females (as % of female labor force) in Spain?
Give a very brief answer. -27.4. In the year 2001, what is the difference between the Educated females (as % of female labor force) in Central Europe and Educated females (as % of female labor force) in Euro area?
Provide a succinct answer. -9.13. In the year 2001, what is the difference between the Educated females (as % of female labor force) in Central Europe and Educated females (as % of female labor force) in Mexico?
Offer a very short reply. -33.34. In the year 2001, what is the difference between the Educated females (as % of female labor force) of Central Europe and Educated females (as % of female labor force) of Spain?
Offer a terse response. -24.34. In the year 2001, what is the difference between the Educated females (as % of female labor force) of Euro area and Educated females (as % of female labor force) of Mexico?
Provide a short and direct response. -24.21. In the year 2001, what is the difference between the Educated females (as % of female labor force) of Euro area and Educated females (as % of female labor force) of Spain?
Provide a short and direct response. -15.21. In the year 2001, what is the difference between the Educated females (as % of female labor force) of Mexico and Educated females (as % of female labor force) of Spain?
Give a very brief answer. 9. In the year 2002, what is the difference between the Educated females (as % of female labor force) of Central Europe and Educated females (as % of female labor force) of Euro area?
Give a very brief answer. -10.47. In the year 2002, what is the difference between the Educated females (as % of female labor force) of Central Europe and Educated females (as % of female labor force) of Mexico?
Offer a very short reply. -0.79. In the year 2002, what is the difference between the Educated females (as % of female labor force) in Central Europe and Educated females (as % of female labor force) in Spain?
Your answer should be very brief. -24.99. In the year 2002, what is the difference between the Educated females (as % of female labor force) in Euro area and Educated females (as % of female labor force) in Mexico?
Provide a short and direct response. 9.68. In the year 2002, what is the difference between the Educated females (as % of female labor force) in Euro area and Educated females (as % of female labor force) in Spain?
Keep it short and to the point. -14.52. In the year 2002, what is the difference between the Educated females (as % of female labor force) in Mexico and Educated females (as % of female labor force) in Spain?
Your answer should be compact. -24.2. In the year 2003, what is the difference between the Educated females (as % of female labor force) in Central Europe and Educated females (as % of female labor force) in Euro area?
Offer a terse response. -10.68. In the year 2003, what is the difference between the Educated females (as % of female labor force) in Central Europe and Educated females (as % of female labor force) in Mexico?
Ensure brevity in your answer.  -1.31. In the year 2003, what is the difference between the Educated females (as % of female labor force) of Central Europe and Educated females (as % of female labor force) of Spain?
Give a very brief answer. -25.11. In the year 2003, what is the difference between the Educated females (as % of female labor force) of Euro area and Educated females (as % of female labor force) of Mexico?
Your answer should be very brief. 9.38. In the year 2003, what is the difference between the Educated females (as % of female labor force) in Euro area and Educated females (as % of female labor force) in Spain?
Your answer should be very brief. -14.42. In the year 2003, what is the difference between the Educated females (as % of female labor force) in Mexico and Educated females (as % of female labor force) in Spain?
Your answer should be very brief. -23.8. In the year 2004, what is the difference between the Educated females (as % of female labor force) in Central Europe and Educated females (as % of female labor force) in Euro area?
Your response must be concise. -10.54. In the year 2004, what is the difference between the Educated females (as % of female labor force) of Central Europe and Educated females (as % of female labor force) of Mexico?
Offer a terse response. -35.97. In the year 2004, what is the difference between the Educated females (as % of female labor force) of Central Europe and Educated females (as % of female labor force) of Spain?
Provide a short and direct response. -23.97. In the year 2004, what is the difference between the Educated females (as % of female labor force) in Euro area and Educated females (as % of female labor force) in Mexico?
Provide a succinct answer. -25.44. In the year 2004, what is the difference between the Educated females (as % of female labor force) of Euro area and Educated females (as % of female labor force) of Spain?
Your response must be concise. -13.44. What is the ratio of the Educated females (as % of female labor force) in Central Europe in 1997 to that in 1998?
Ensure brevity in your answer.  1.15. What is the ratio of the Educated females (as % of female labor force) of Euro area in 1997 to that in 1998?
Give a very brief answer. 0.88. What is the ratio of the Educated females (as % of female labor force) in Mexico in 1997 to that in 1998?
Your answer should be compact. 0.59. What is the ratio of the Educated females (as % of female labor force) in Spain in 1997 to that in 1998?
Your response must be concise. 1.01. What is the ratio of the Educated females (as % of female labor force) in Central Europe in 1997 to that in 1999?
Provide a short and direct response. 1.2. What is the ratio of the Educated females (as % of female labor force) in Euro area in 1997 to that in 1999?
Keep it short and to the point. 1.04. What is the ratio of the Educated females (as % of female labor force) of Mexico in 1997 to that in 1999?
Make the answer very short. 1.81. What is the ratio of the Educated females (as % of female labor force) in Spain in 1997 to that in 1999?
Provide a succinct answer. 1.05. What is the ratio of the Educated females (as % of female labor force) in Central Europe in 1997 to that in 2000?
Provide a succinct answer. 1.23. What is the ratio of the Educated females (as % of female labor force) in Euro area in 1997 to that in 2000?
Your answer should be very brief. 1.09. What is the ratio of the Educated females (as % of female labor force) of Mexico in 1997 to that in 2000?
Offer a terse response. 1.89. What is the ratio of the Educated females (as % of female labor force) in Spain in 1997 to that in 2000?
Your answer should be compact. 1.09. What is the ratio of the Educated females (as % of female labor force) in Central Europe in 1997 to that in 2001?
Offer a terse response. 1.29. What is the ratio of the Educated females (as % of female labor force) of Euro area in 1997 to that in 2001?
Offer a terse response. 1.13. What is the ratio of the Educated females (as % of female labor force) in Mexico in 1997 to that in 2001?
Provide a succinct answer. 0.7. What is the ratio of the Educated females (as % of female labor force) of Spain in 1997 to that in 2001?
Keep it short and to the point. 1.14. What is the ratio of the Educated females (as % of female labor force) in Central Europe in 1997 to that in 2002?
Offer a very short reply. 1.43. What is the ratio of the Educated females (as % of female labor force) in Euro area in 1997 to that in 2002?
Offer a very short reply. 1.15. What is the ratio of the Educated females (as % of female labor force) in Mexico in 1997 to that in 2002?
Offer a terse response. 1.95. What is the ratio of the Educated females (as % of female labor force) in Spain in 1997 to that in 2002?
Offer a terse response. 1.18. What is the ratio of the Educated females (as % of female labor force) in Central Europe in 1997 to that in 2003?
Offer a very short reply. 1.51. What is the ratio of the Educated females (as % of female labor force) of Euro area in 1997 to that in 2003?
Offer a terse response. 1.18. What is the ratio of the Educated females (as % of female labor force) in Mexico in 1997 to that in 2003?
Give a very brief answer. 1.99. What is the ratio of the Educated females (as % of female labor force) in Spain in 1997 to that in 2003?
Provide a succinct answer. 1.2. What is the ratio of the Educated females (as % of female labor force) in Central Europe in 1997 to that in 2004?
Your answer should be compact. 1.61. What is the ratio of the Educated females (as % of female labor force) of Euro area in 1997 to that in 2004?
Provide a succinct answer. 1.24. What is the ratio of the Educated females (as % of female labor force) of Mexico in 1997 to that in 2004?
Offer a very short reply. 0.72. What is the ratio of the Educated females (as % of female labor force) of Spain in 1997 to that in 2004?
Give a very brief answer. 1.27. What is the ratio of the Educated females (as % of female labor force) in Central Europe in 1998 to that in 1999?
Give a very brief answer. 1.04. What is the ratio of the Educated females (as % of female labor force) of Euro area in 1998 to that in 1999?
Ensure brevity in your answer.  1.19. What is the ratio of the Educated females (as % of female labor force) of Mexico in 1998 to that in 1999?
Make the answer very short. 3.04. What is the ratio of the Educated females (as % of female labor force) of Spain in 1998 to that in 1999?
Provide a succinct answer. 1.04. What is the ratio of the Educated females (as % of female labor force) in Central Europe in 1998 to that in 2000?
Give a very brief answer. 1.07. What is the ratio of the Educated females (as % of female labor force) in Euro area in 1998 to that in 2000?
Offer a very short reply. 1.24. What is the ratio of the Educated females (as % of female labor force) of Mexico in 1998 to that in 2000?
Your response must be concise. 3.18. What is the ratio of the Educated females (as % of female labor force) of Spain in 1998 to that in 2000?
Ensure brevity in your answer.  1.08. What is the ratio of the Educated females (as % of female labor force) of Central Europe in 1998 to that in 2001?
Provide a succinct answer. 1.13. What is the ratio of the Educated females (as % of female labor force) in Euro area in 1998 to that in 2001?
Provide a short and direct response. 1.29. What is the ratio of the Educated females (as % of female labor force) of Mexico in 1998 to that in 2001?
Your answer should be compact. 1.18. What is the ratio of the Educated females (as % of female labor force) of Spain in 1998 to that in 2001?
Your response must be concise. 1.13. What is the ratio of the Educated females (as % of female labor force) of Central Europe in 1998 to that in 2002?
Provide a succinct answer. 1.25. What is the ratio of the Educated females (as % of female labor force) in Euro area in 1998 to that in 2002?
Provide a succinct answer. 1.32. What is the ratio of the Educated females (as % of female labor force) of Mexico in 1998 to that in 2002?
Offer a terse response. 3.28. What is the ratio of the Educated females (as % of female labor force) of Spain in 1998 to that in 2002?
Offer a very short reply. 1.17. What is the ratio of the Educated females (as % of female labor force) of Central Europe in 1998 to that in 2003?
Keep it short and to the point. 1.32. What is the ratio of the Educated females (as % of female labor force) in Euro area in 1998 to that in 2003?
Your answer should be compact. 1.35. What is the ratio of the Educated females (as % of female labor force) of Mexico in 1998 to that in 2003?
Provide a succinct answer. 3.35. What is the ratio of the Educated females (as % of female labor force) in Spain in 1998 to that in 2003?
Keep it short and to the point. 1.19. What is the ratio of the Educated females (as % of female labor force) of Central Europe in 1998 to that in 2004?
Provide a short and direct response. 1.41. What is the ratio of the Educated females (as % of female labor force) in Euro area in 1998 to that in 2004?
Your answer should be very brief. 1.42. What is the ratio of the Educated females (as % of female labor force) of Mexico in 1998 to that in 2004?
Your response must be concise. 1.21. What is the ratio of the Educated females (as % of female labor force) in Spain in 1998 to that in 2004?
Provide a succinct answer. 1.26. What is the ratio of the Educated females (as % of female labor force) of Central Europe in 1999 to that in 2000?
Offer a very short reply. 1.03. What is the ratio of the Educated females (as % of female labor force) in Euro area in 1999 to that in 2000?
Make the answer very short. 1.04. What is the ratio of the Educated females (as % of female labor force) of Mexico in 1999 to that in 2000?
Make the answer very short. 1.04. What is the ratio of the Educated females (as % of female labor force) in Spain in 1999 to that in 2000?
Make the answer very short. 1.03. What is the ratio of the Educated females (as % of female labor force) of Central Europe in 1999 to that in 2001?
Make the answer very short. 1.08. What is the ratio of the Educated females (as % of female labor force) in Euro area in 1999 to that in 2001?
Your answer should be compact. 1.08. What is the ratio of the Educated females (as % of female labor force) in Mexico in 1999 to that in 2001?
Your answer should be very brief. 0.39. What is the ratio of the Educated females (as % of female labor force) of Spain in 1999 to that in 2001?
Provide a short and direct response. 1.09. What is the ratio of the Educated females (as % of female labor force) of Central Europe in 1999 to that in 2002?
Keep it short and to the point. 1.2. What is the ratio of the Educated females (as % of female labor force) in Euro area in 1999 to that in 2002?
Make the answer very short. 1.11. What is the ratio of the Educated females (as % of female labor force) of Mexico in 1999 to that in 2002?
Your answer should be compact. 1.08. What is the ratio of the Educated females (as % of female labor force) in Spain in 1999 to that in 2002?
Ensure brevity in your answer.  1.12. What is the ratio of the Educated females (as % of female labor force) of Central Europe in 1999 to that in 2003?
Provide a succinct answer. 1.26. What is the ratio of the Educated females (as % of female labor force) of Euro area in 1999 to that in 2003?
Keep it short and to the point. 1.13. What is the ratio of the Educated females (as % of female labor force) of Mexico in 1999 to that in 2003?
Your answer should be compact. 1.1. What is the ratio of the Educated females (as % of female labor force) of Spain in 1999 to that in 2003?
Give a very brief answer. 1.14. What is the ratio of the Educated females (as % of female labor force) in Central Europe in 1999 to that in 2004?
Ensure brevity in your answer.  1.35. What is the ratio of the Educated females (as % of female labor force) in Euro area in 1999 to that in 2004?
Your answer should be very brief. 1.19. What is the ratio of the Educated females (as % of female labor force) of Mexico in 1999 to that in 2004?
Keep it short and to the point. 0.4. What is the ratio of the Educated females (as % of female labor force) of Spain in 1999 to that in 2004?
Offer a terse response. 1.21. What is the ratio of the Educated females (as % of female labor force) in Central Europe in 2000 to that in 2001?
Give a very brief answer. 1.05. What is the ratio of the Educated females (as % of female labor force) of Euro area in 2000 to that in 2001?
Provide a succinct answer. 1.04. What is the ratio of the Educated females (as % of female labor force) in Mexico in 2000 to that in 2001?
Make the answer very short. 0.37. What is the ratio of the Educated females (as % of female labor force) of Spain in 2000 to that in 2001?
Your answer should be compact. 1.05. What is the ratio of the Educated females (as % of female labor force) in Central Europe in 2000 to that in 2002?
Provide a succinct answer. 1.17. What is the ratio of the Educated females (as % of female labor force) of Euro area in 2000 to that in 2002?
Give a very brief answer. 1.06. What is the ratio of the Educated females (as % of female labor force) of Mexico in 2000 to that in 2002?
Keep it short and to the point. 1.03. What is the ratio of the Educated females (as % of female labor force) in Spain in 2000 to that in 2002?
Give a very brief answer. 1.09. What is the ratio of the Educated females (as % of female labor force) of Central Europe in 2000 to that in 2003?
Your answer should be compact. 1.23. What is the ratio of the Educated females (as % of female labor force) in Euro area in 2000 to that in 2003?
Provide a succinct answer. 1.09. What is the ratio of the Educated females (as % of female labor force) in Mexico in 2000 to that in 2003?
Ensure brevity in your answer.  1.05. What is the ratio of the Educated females (as % of female labor force) in Spain in 2000 to that in 2003?
Your answer should be compact. 1.11. What is the ratio of the Educated females (as % of female labor force) of Central Europe in 2000 to that in 2004?
Ensure brevity in your answer.  1.32. What is the ratio of the Educated females (as % of female labor force) of Euro area in 2000 to that in 2004?
Ensure brevity in your answer.  1.14. What is the ratio of the Educated females (as % of female labor force) in Mexico in 2000 to that in 2004?
Keep it short and to the point. 0.38. What is the ratio of the Educated females (as % of female labor force) in Spain in 2000 to that in 2004?
Ensure brevity in your answer.  1.17. What is the ratio of the Educated females (as % of female labor force) of Central Europe in 2001 to that in 2002?
Give a very brief answer. 1.11. What is the ratio of the Educated females (as % of female labor force) in Euro area in 2001 to that in 2002?
Provide a short and direct response. 1.02. What is the ratio of the Educated females (as % of female labor force) in Mexico in 2001 to that in 2002?
Your answer should be very brief. 2.77. What is the ratio of the Educated females (as % of female labor force) of Spain in 2001 to that in 2002?
Your answer should be compact. 1.03. What is the ratio of the Educated females (as % of female labor force) of Central Europe in 2001 to that in 2003?
Offer a terse response. 1.17. What is the ratio of the Educated females (as % of female labor force) in Euro area in 2001 to that in 2003?
Keep it short and to the point. 1.05. What is the ratio of the Educated females (as % of female labor force) in Mexico in 2001 to that in 2003?
Offer a terse response. 2.83. What is the ratio of the Educated females (as % of female labor force) in Spain in 2001 to that in 2003?
Make the answer very short. 1.05. What is the ratio of the Educated females (as % of female labor force) in Central Europe in 2001 to that in 2004?
Give a very brief answer. 1.25. What is the ratio of the Educated females (as % of female labor force) in Euro area in 2001 to that in 2004?
Provide a short and direct response. 1.1. What is the ratio of the Educated females (as % of female labor force) of Mexico in 2001 to that in 2004?
Make the answer very short. 1.03. What is the ratio of the Educated females (as % of female labor force) of Spain in 2001 to that in 2004?
Offer a terse response. 1.11. What is the ratio of the Educated females (as % of female labor force) of Central Europe in 2002 to that in 2003?
Offer a very short reply. 1.05. What is the ratio of the Educated females (as % of female labor force) in Euro area in 2002 to that in 2003?
Offer a very short reply. 1.02. What is the ratio of the Educated females (as % of female labor force) in Mexico in 2002 to that in 2003?
Ensure brevity in your answer.  1.02. What is the ratio of the Educated females (as % of female labor force) in Spain in 2002 to that in 2003?
Provide a succinct answer. 1.02. What is the ratio of the Educated females (as % of female labor force) in Central Europe in 2002 to that in 2004?
Give a very brief answer. 1.13. What is the ratio of the Educated females (as % of female labor force) in Euro area in 2002 to that in 2004?
Your answer should be very brief. 1.07. What is the ratio of the Educated females (as % of female labor force) in Mexico in 2002 to that in 2004?
Keep it short and to the point. 0.37. What is the ratio of the Educated females (as % of female labor force) in Spain in 2002 to that in 2004?
Offer a very short reply. 1.08. What is the ratio of the Educated females (as % of female labor force) of Central Europe in 2003 to that in 2004?
Your answer should be compact. 1.07. What is the ratio of the Educated females (as % of female labor force) of Euro area in 2003 to that in 2004?
Provide a short and direct response. 1.05. What is the ratio of the Educated females (as % of female labor force) in Mexico in 2003 to that in 2004?
Your answer should be compact. 0.36. What is the ratio of the Educated females (as % of female labor force) of Spain in 2003 to that in 2004?
Give a very brief answer. 1.06. What is the difference between the highest and the second highest Educated females (as % of female labor force) of Central Europe?
Make the answer very short. 3.42. What is the difference between the highest and the second highest Educated females (as % of female labor force) in Euro area?
Your answer should be compact. 4.8. What is the difference between the highest and the second highest Educated females (as % of female labor force) of Mexico?
Offer a terse response. 9.8. What is the difference between the highest and the second highest Educated females (as % of female labor force) in Spain?
Offer a very short reply. 0.5. What is the difference between the highest and the lowest Educated females (as % of female labor force) of Central Europe?
Your response must be concise. 10.21. What is the difference between the highest and the lowest Educated females (as % of female labor force) in Euro area?
Offer a very short reply. 11.33. What is the difference between the highest and the lowest Educated females (as % of female labor force) of Mexico?
Offer a very short reply. 44.8. 